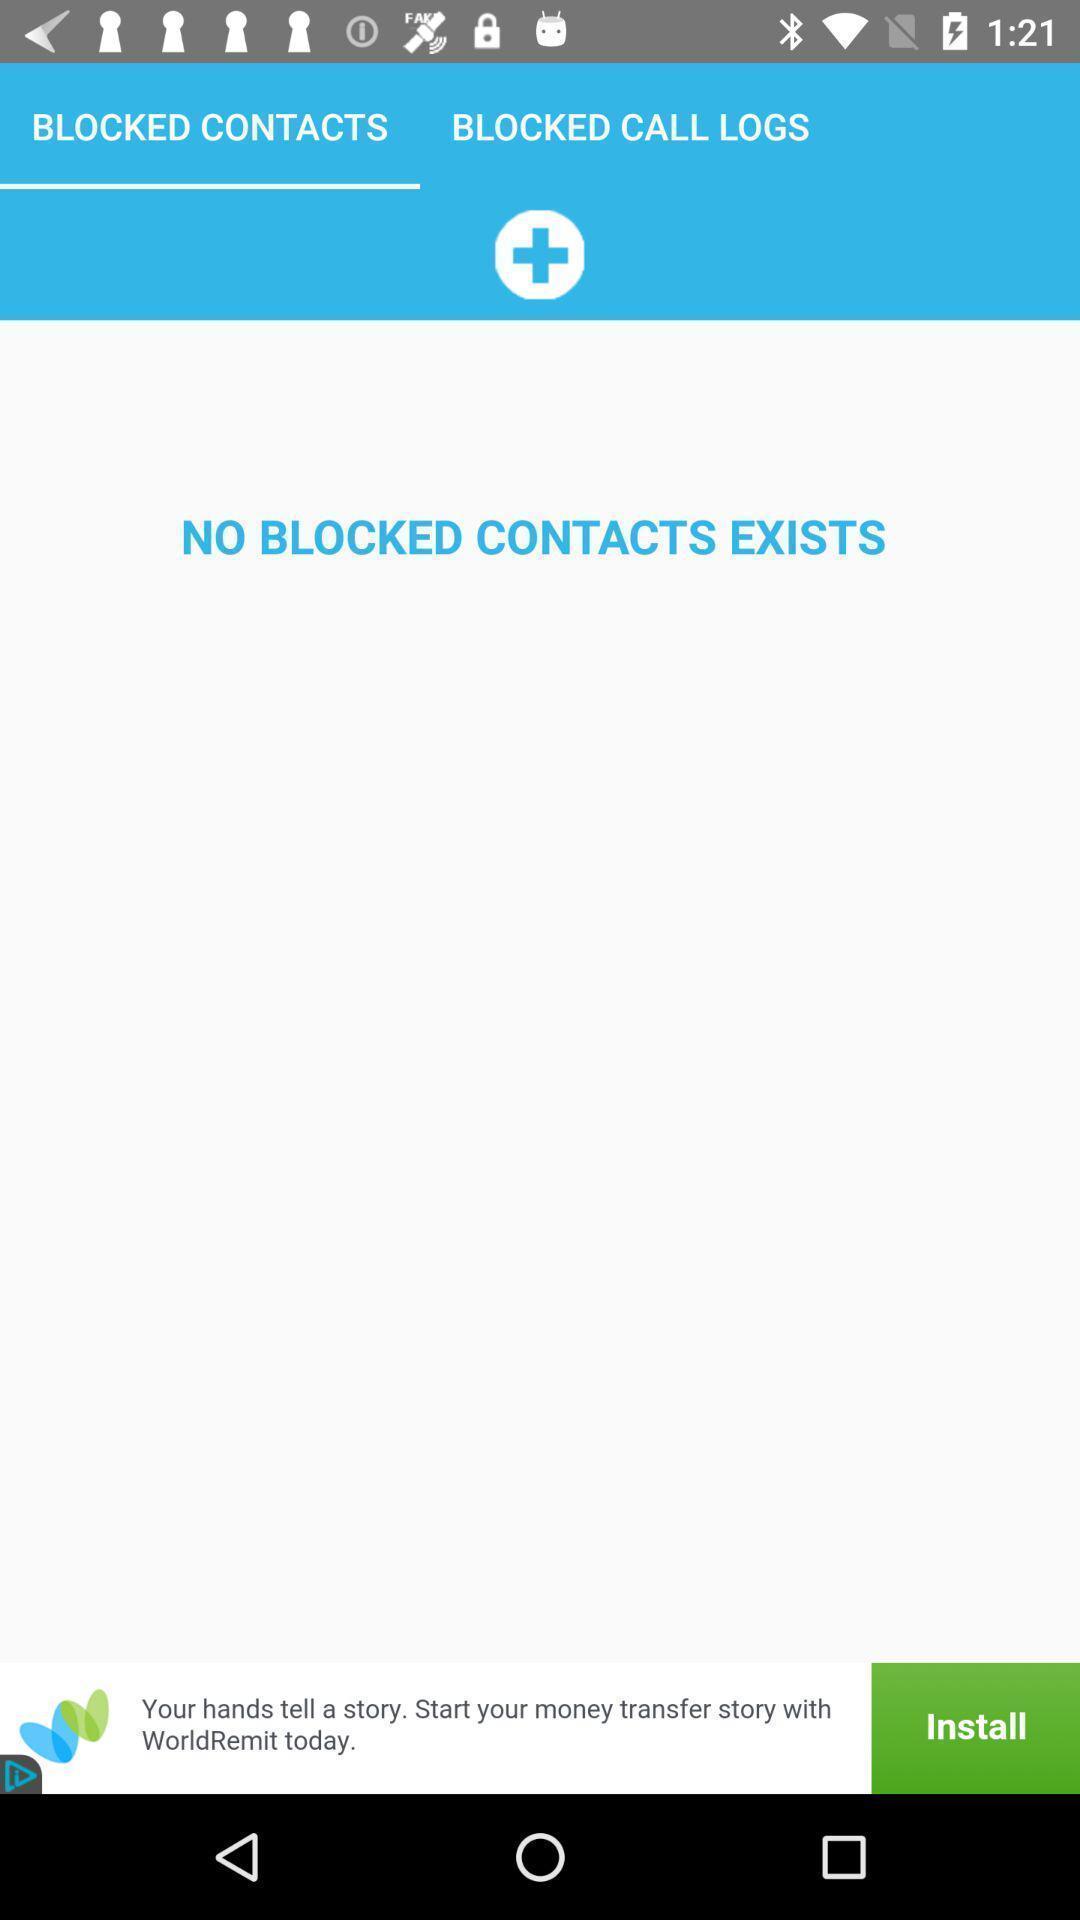Describe the key features of this screenshot. Screen displaying the page of blocked contacts. 